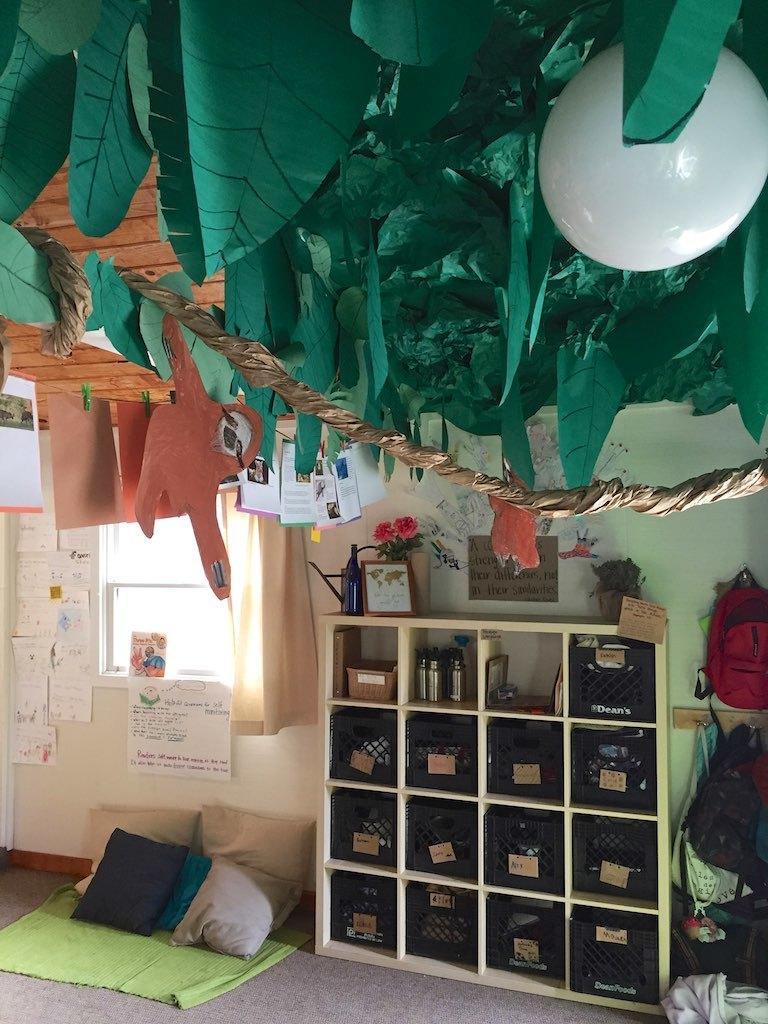Can you describe this image briefly? In the picture we can see an inside view of the house with some racks and something kept at it and beside the tracks, we can see a floor mat with some pillows on it and on the other side, we can see some bags are hung to the wall and to the wall we can see a window and beside it we can see some papers are past and to the ceiling we can see some colored papers and white color balloon is decorated to it. 